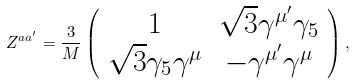Convert formula to latex. <formula><loc_0><loc_0><loc_500><loc_500>Z ^ { a a ^ { \prime } } = \frac { 3 } { M } \left ( \begin{array} { c c } 1 & \sqrt { 3 } \gamma ^ { \mu ^ { \prime } } \gamma _ { 5 } \\ \sqrt { 3 } \gamma _ { 5 } \gamma ^ { \mu } & - \gamma ^ { \mu ^ { \prime } } \gamma ^ { \mu } \\ \end{array} \right ) ,</formula> 